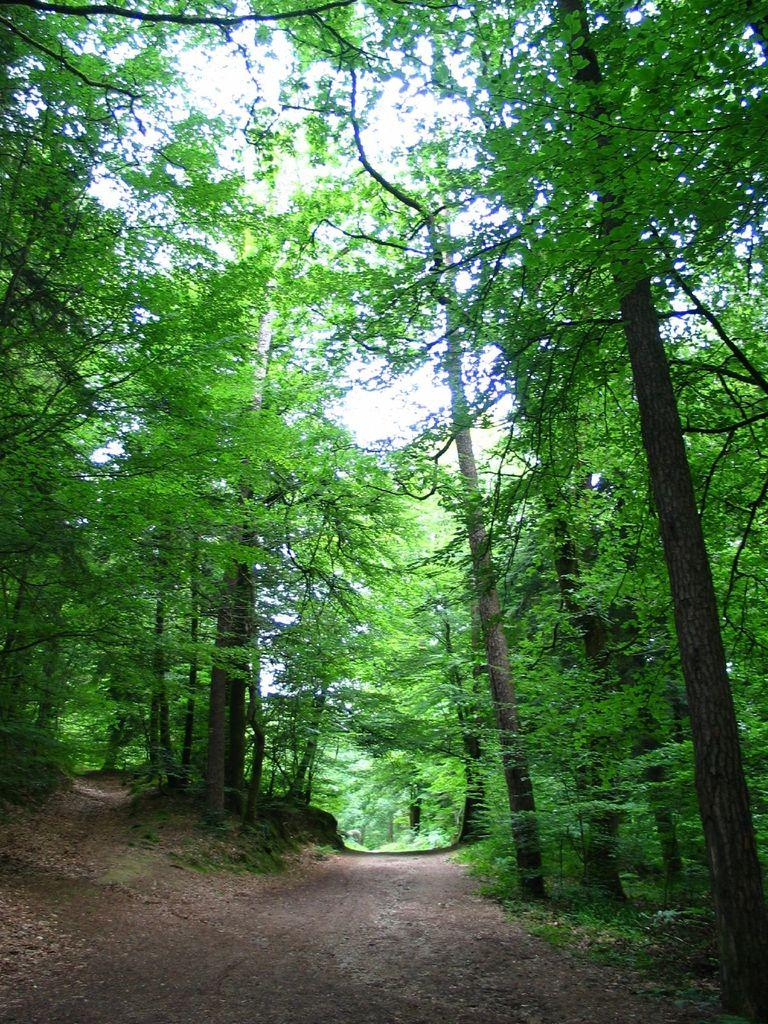What type of natural vegetation is present in the image? There are many trees in the image. What can be seen in the background of the image? The sky is visible in the background of the image. What type of net is being used to catch fish in the image? There is no net or fish present in the image; it only features trees and the sky. 